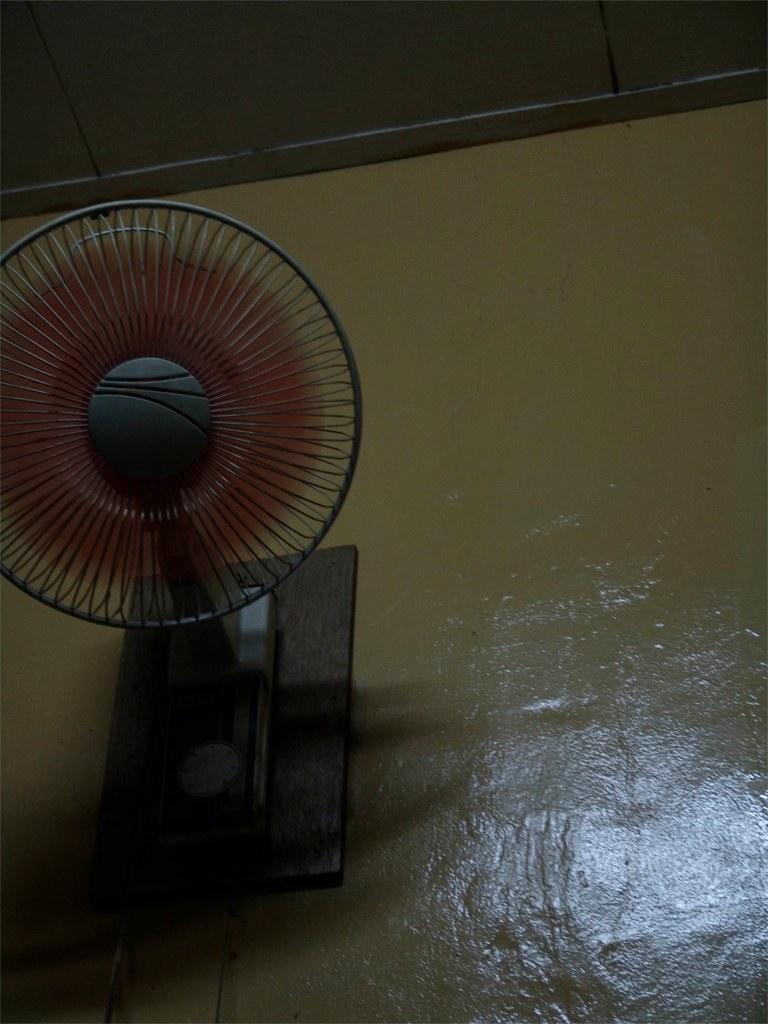What object is located on the left side of the image? There is a fan on the left side of the image. What else can be seen on the left side of the image? There is a board on the left side of the image. What is visible in the background of the image? There is a wall in the background of the image. What is visible at the top of the image? There is a roof visible at the top of the image. Where is the cup located in the image? There is no cup present in the image. What type of twig is growing on the wall in the image? There is no twig visible on the wall in the image. 